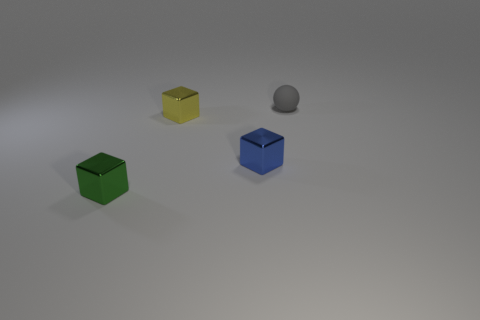Subtract all small blue blocks. How many blocks are left? 2 Subtract all yellow cubes. How many cubes are left? 2 Subtract all cubes. How many objects are left? 1 Add 4 small yellow objects. How many objects exist? 8 Subtract all blue cubes. Subtract all gray cylinders. How many cubes are left? 2 Subtract all small green rubber things. Subtract all blue metal things. How many objects are left? 3 Add 2 spheres. How many spheres are left? 3 Add 4 cyan things. How many cyan things exist? 4 Subtract 0 red blocks. How many objects are left? 4 